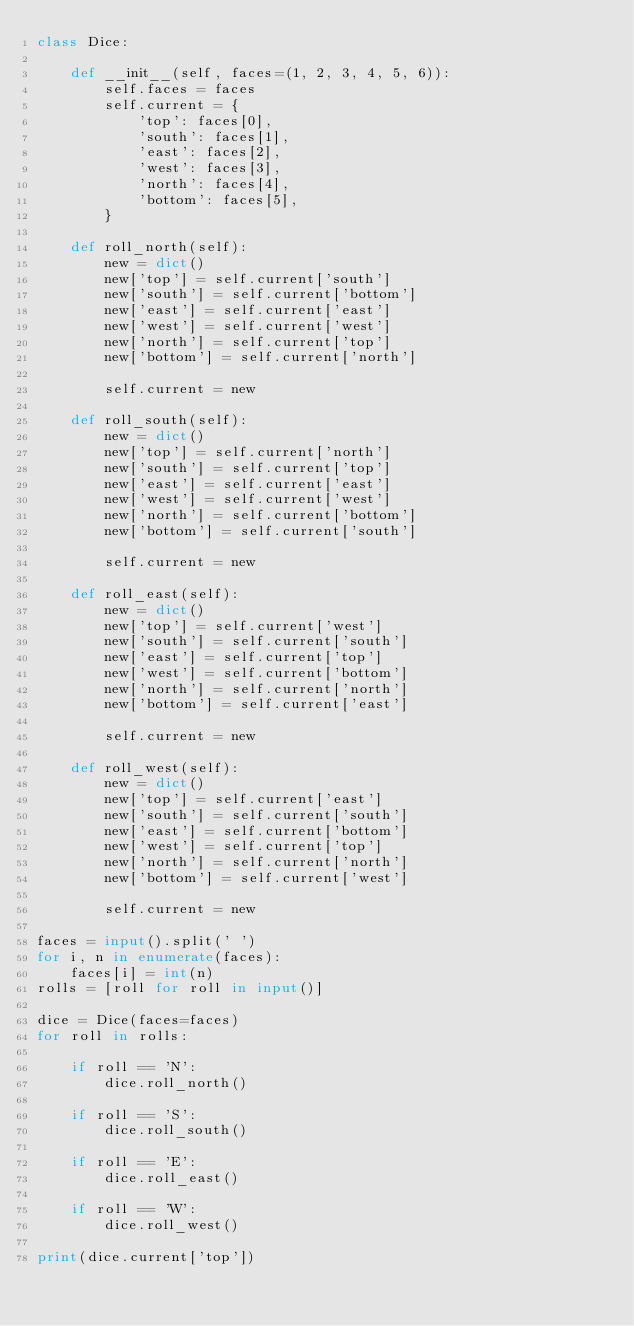Convert code to text. <code><loc_0><loc_0><loc_500><loc_500><_Python_>class Dice:

    def __init__(self, faces=(1, 2, 3, 4, 5, 6)):
        self.faces = faces
        self.current = {
            'top': faces[0],
            'south': faces[1],
            'east': faces[2],
            'west': faces[3],
            'north': faces[4],
            'bottom': faces[5],
        }

    def roll_north(self):
        new = dict()
        new['top'] = self.current['south']
        new['south'] = self.current['bottom']
        new['east'] = self.current['east']
        new['west'] = self.current['west']
        new['north'] = self.current['top']
        new['bottom'] = self.current['north']

        self.current = new

    def roll_south(self):
        new = dict()
        new['top'] = self.current['north']
        new['south'] = self.current['top']
        new['east'] = self.current['east']
        new['west'] = self.current['west']
        new['north'] = self.current['bottom']
        new['bottom'] = self.current['south']

        self.current = new

    def roll_east(self):
        new = dict()
        new['top'] = self.current['west']
        new['south'] = self.current['south']
        new['east'] = self.current['top']
        new['west'] = self.current['bottom']
        new['north'] = self.current['north']
        new['bottom'] = self.current['east']

        self.current = new

    def roll_west(self):
        new = dict()
        new['top'] = self.current['east']
        new['south'] = self.current['south']
        new['east'] = self.current['bottom']
        new['west'] = self.current['top']
        new['north'] = self.current['north']
        new['bottom'] = self.current['west']

        self.current = new

faces = input().split(' ')
for i, n in enumerate(faces):
    faces[i] = int(n)
rolls = [roll for roll in input()]

dice = Dice(faces=faces)
for roll in rolls:

    if roll == 'N':
        dice.roll_north()

    if roll == 'S':
        dice.roll_south()

    if roll == 'E':
        dice.roll_east()

    if roll == 'W':
        dice.roll_west()

print(dice.current['top'])
</code> 